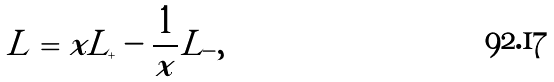Convert formula to latex. <formula><loc_0><loc_0><loc_500><loc_500>L = x L _ { + } - \frac { 1 } { x } L _ { - } ,</formula> 